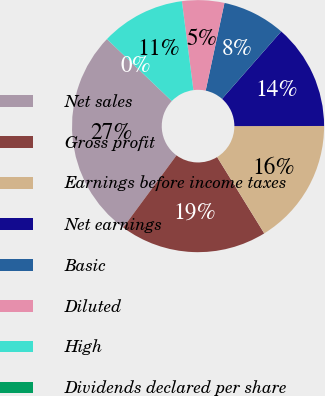<chart> <loc_0><loc_0><loc_500><loc_500><pie_chart><fcel>Net sales<fcel>Gross profit<fcel>Earnings before income taxes<fcel>Net earnings<fcel>Basic<fcel>Diluted<fcel>High<fcel>Dividends declared per share<nl><fcel>27.02%<fcel>18.92%<fcel>16.22%<fcel>13.51%<fcel>8.11%<fcel>5.41%<fcel>10.81%<fcel>0.0%<nl></chart> 